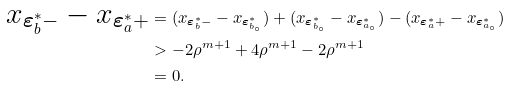<formula> <loc_0><loc_0><loc_500><loc_500>x _ { \boldsymbol \varepsilon _ { b } ^ { * } - } - x _ { \boldsymbol \varepsilon _ { a } ^ { * } + } & = ( x _ { \boldsymbol \varepsilon _ { b } ^ { * } - } - x _ { \boldsymbol \varepsilon _ { b _ { \circ } } ^ { * } } ) + ( x _ { \boldsymbol \varepsilon _ { b _ { \circ } } ^ { * } } - x _ { \boldsymbol \varepsilon _ { a _ { \circ } } ^ { * } } ) - ( x _ { \boldsymbol \varepsilon _ { a } ^ { * } + } - x _ { \boldsymbol \varepsilon _ { a _ { \circ } } ^ { * } } ) \\ & > - 2 \rho ^ { m + 1 } + 4 \rho ^ { m + 1 } - 2 \rho ^ { m + 1 } \\ & = 0 .</formula> 